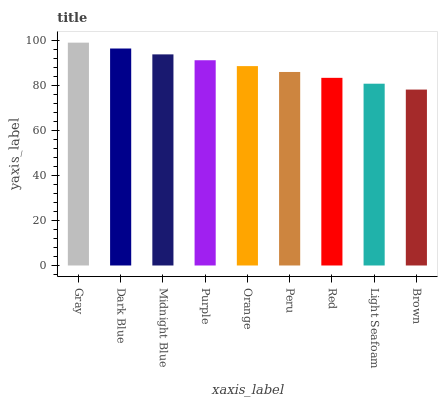Is Brown the minimum?
Answer yes or no. Yes. Is Gray the maximum?
Answer yes or no. Yes. Is Dark Blue the minimum?
Answer yes or no. No. Is Dark Blue the maximum?
Answer yes or no. No. Is Gray greater than Dark Blue?
Answer yes or no. Yes. Is Dark Blue less than Gray?
Answer yes or no. Yes. Is Dark Blue greater than Gray?
Answer yes or no. No. Is Gray less than Dark Blue?
Answer yes or no. No. Is Orange the high median?
Answer yes or no. Yes. Is Orange the low median?
Answer yes or no. Yes. Is Dark Blue the high median?
Answer yes or no. No. Is Purple the low median?
Answer yes or no. No. 